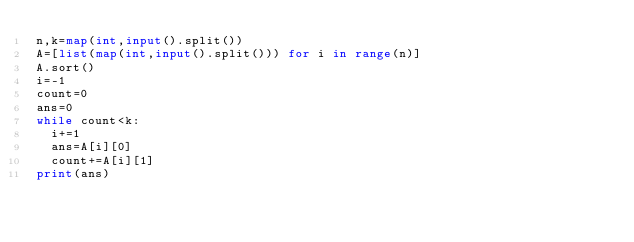<code> <loc_0><loc_0><loc_500><loc_500><_Python_>n,k=map(int,input().split())
A=[list(map(int,input().split())) for i in range(n)]
A.sort()
i=-1
count=0
ans=0
while count<k:
  i+=1
  ans=A[i][0]
  count+=A[i][1]
print(ans)</code> 